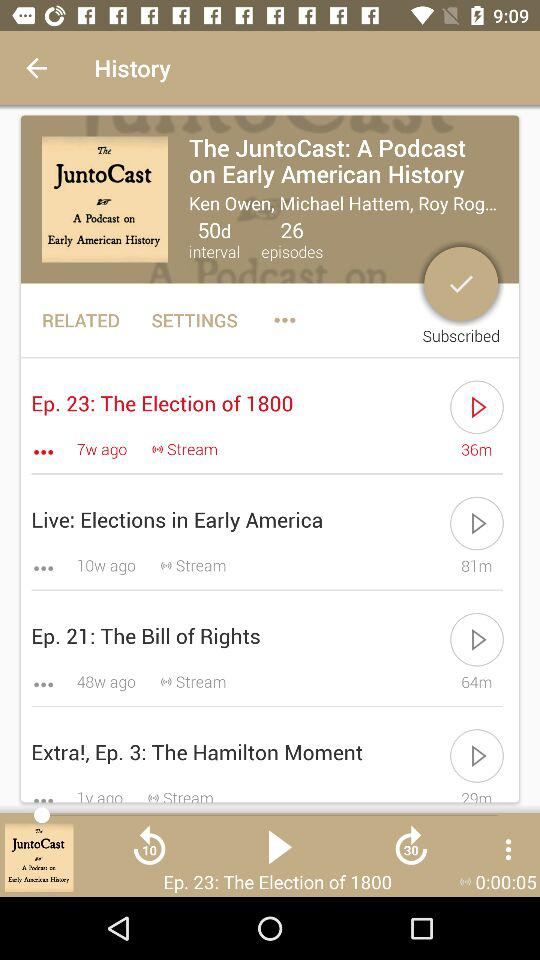Which episode was last played? The last played episode was "The Election of 1800". 